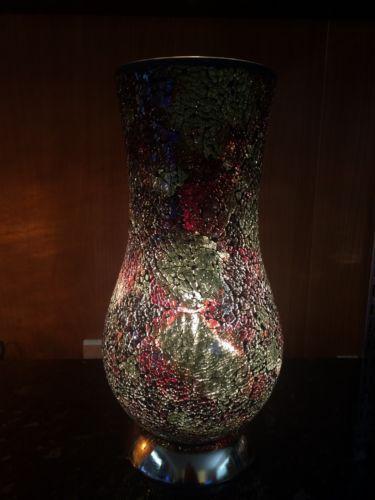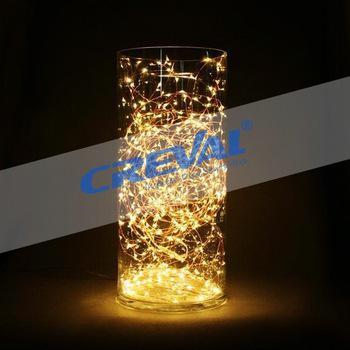The first image is the image on the left, the second image is the image on the right. For the images shown, is this caption "One of the two vases is glowing yellow." true? Answer yes or no. Yes. The first image is the image on the left, the second image is the image on the right. Assess this claim about the two images: "In at least one image  there is a white and black speckled vase with a solid black top and bottom.". Correct or not? Answer yes or no. No. 